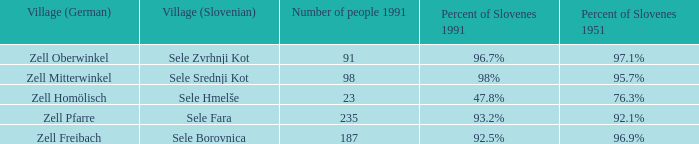Give me the minimum number of people in 1991 with 92.5% of Slovenes in 1991. 187.0. 